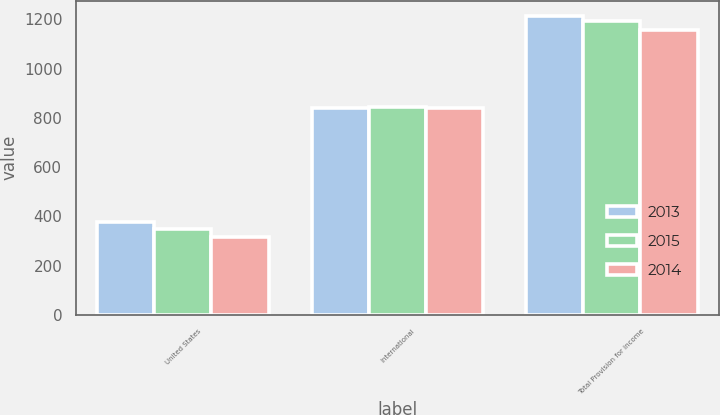<chart> <loc_0><loc_0><loc_500><loc_500><stacked_bar_chart><ecel><fcel>United States<fcel>International<fcel>Total Provision for income<nl><fcel>2013<fcel>376<fcel>839<fcel>1215<nl><fcel>2015<fcel>348<fcel>846<fcel>1194<nl><fcel>2014<fcel>314<fcel>841<fcel>1155<nl></chart> 